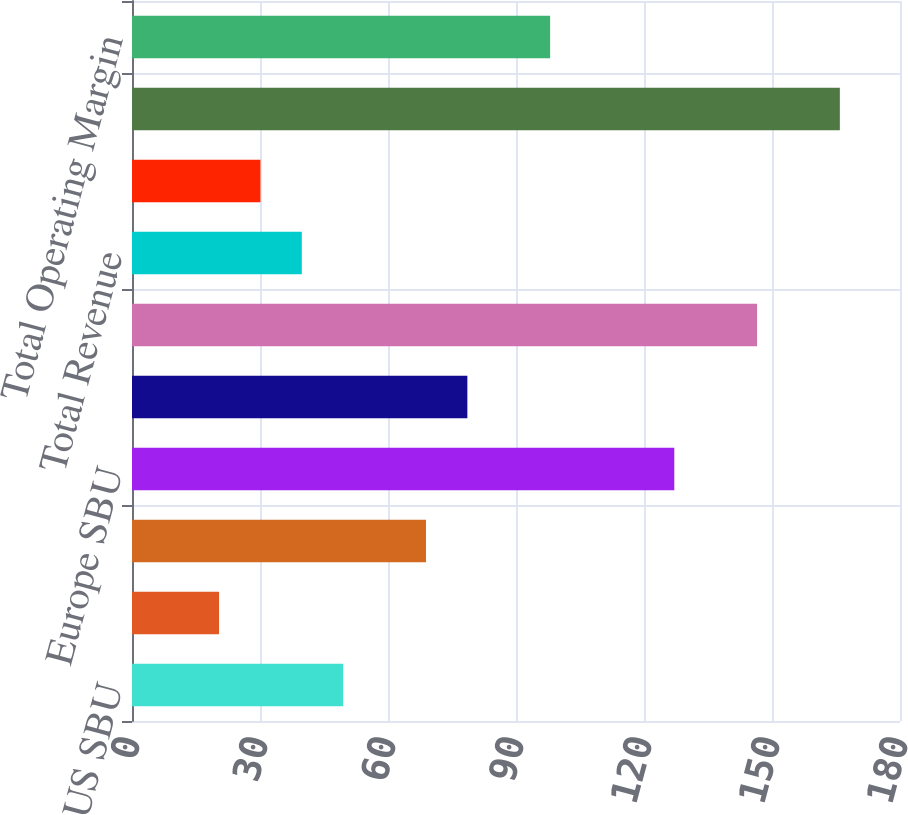<chart> <loc_0><loc_0><loc_500><loc_500><bar_chart><fcel>US SBU<fcel>Brazil SBU<fcel>MCAC SBU<fcel>Europe SBU<fcel>Asia SBU<fcel>Intersegment eliminations<fcel>Total Revenue<fcel>Andes SBU<fcel>Corporate and Other<fcel>Total Operating Margin<nl><fcel>49.5<fcel>20.4<fcel>68.9<fcel>127.1<fcel>78.6<fcel>146.5<fcel>39.8<fcel>30.1<fcel>165.9<fcel>98<nl></chart> 